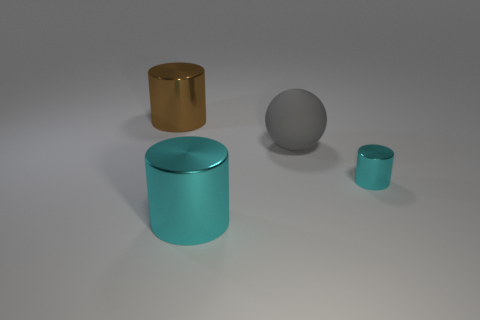Are there any other things that have the same material as the big sphere?
Provide a short and direct response. No. There is a brown shiny object; does it have the same shape as the large cyan thing in front of the gray matte ball?
Keep it short and to the point. Yes. Is there a rubber thing that has the same color as the rubber sphere?
Keep it short and to the point. No. What is the size of the brown cylinder that is made of the same material as the small cyan cylinder?
Offer a very short reply. Large. Does the small cylinder have the same color as the big rubber sphere?
Keep it short and to the point. No. Does the object behind the sphere have the same shape as the large rubber object?
Make the answer very short. No. How many brown shiny things are the same size as the gray rubber sphere?
Give a very brief answer. 1. There is a large cylinder in front of the big brown shiny thing; are there any large rubber objects left of it?
Your answer should be compact. No. What number of things are cylinders that are behind the small cyan cylinder or small purple cubes?
Ensure brevity in your answer.  1. How many cyan metal objects are there?
Offer a terse response. 2. 